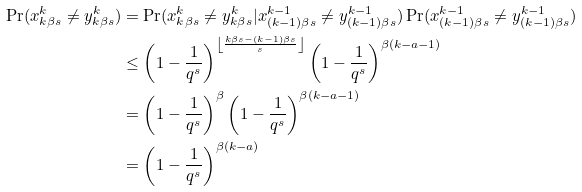<formula> <loc_0><loc_0><loc_500><loc_500>\Pr ( x _ { k \beta s } ^ { k } \neq y _ { k \beta s } ^ { k } ) & = \Pr ( x _ { k \beta s } ^ { k } \neq y _ { k \beta s } ^ { k } | x _ { ( k - 1 ) \beta s } ^ { k - 1 } \neq y _ { ( k - 1 ) \beta s } ^ { k - 1 } ) \Pr ( x _ { ( k - 1 ) \beta s } ^ { k - 1 } \neq y _ { ( k - 1 ) \beta s } ^ { k - 1 } ) \\ & \leq \left ( 1 - \frac { 1 } { q ^ { s } } \right ) ^ { \left \lfloor \frac { k \beta s - ( k - 1 ) \beta s } { s } \right \rfloor } \left ( 1 - \frac { 1 } { q ^ { s } } \right ) ^ { \beta ( k - a - 1 ) } \\ & = \left ( 1 - \frac { 1 } { q ^ { s } } \right ) ^ { \beta } \left ( 1 - \frac { 1 } { q ^ { s } } \right ) ^ { \beta ( k - a - 1 ) } \\ & = \left ( 1 - \frac { 1 } { q ^ { s } } \right ) ^ { \beta ( k - a ) }</formula> 